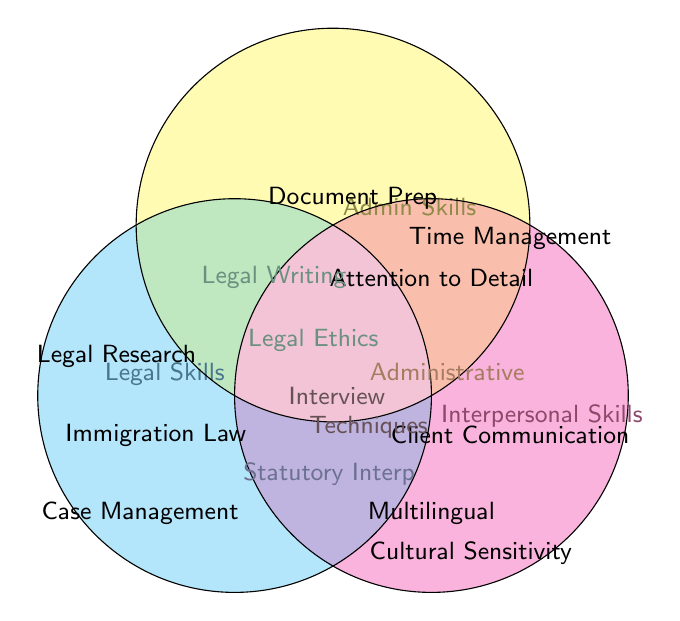What are the three main categories of skills displayed in the Venn diagram? The Venn diagram displays three main categories of skills, which are labeled directly on the circles.
Answer: Legal Skills, Admin Skills, Interpersonal Skills Which skills fall under the Legal Skills category? The skills that fall under the Legal Skills category are within the cyan circle.
Answer: Legal Research, Immigration Law Knowledge, Case Management, Legal Ethics, Statutory Interpretation Which skills are shared between Admin Skills and Interpersonal Skills but not Legal Skills? By looking at the intersection between the yellow (Admin Skills) and magenta (Interpersonal Skills) circles, and excluding any overlap with the cyan (Legal Skills) circle, we identify the shared skills.
Answer: Administrative Skills Are there any skills common to all three skill categories? The skills common to all three categories will be located at the intersection of the cyan, yellow, and magenta circles.
Answer: Interview Techniques What is the skill common between Legal Skills and Admin Skills? By observing the intersection between the cyan (Legal Skills) and yellow (Admin Skills) circles, we can identify the shared skills.
Answer: Legal Writing, Legal Ethics Which skill is unique to Interpersonal Skills? The unique skill in the magenta circle, not overlapping with any other circle, is identified as a unique skill in the Interpersonal Skills category.
Answer: Cultural Sensitivity How many skills are listed under Admin Skills? Counting all the skills within the yellow circle will give the total number of Admin Skills.
Answer: 5 Which category encompasses Legal Writing and where do these skills intersect? Legal Writing falls under the intersection of Legal Skills and Admin Skills, as depicted within the overlapping section between the cyan and yellow circles.
Answer: Legal Skills and Admin Skills Is Attention to Detail considered an Interpersonal Skill? Attention to Detail is located within the yellow circle (Admin Skills), and it does not overlap with the magenta circle (Interpersonal Skills), showing that it is not an Interpersonal Skill.
Answer: No 